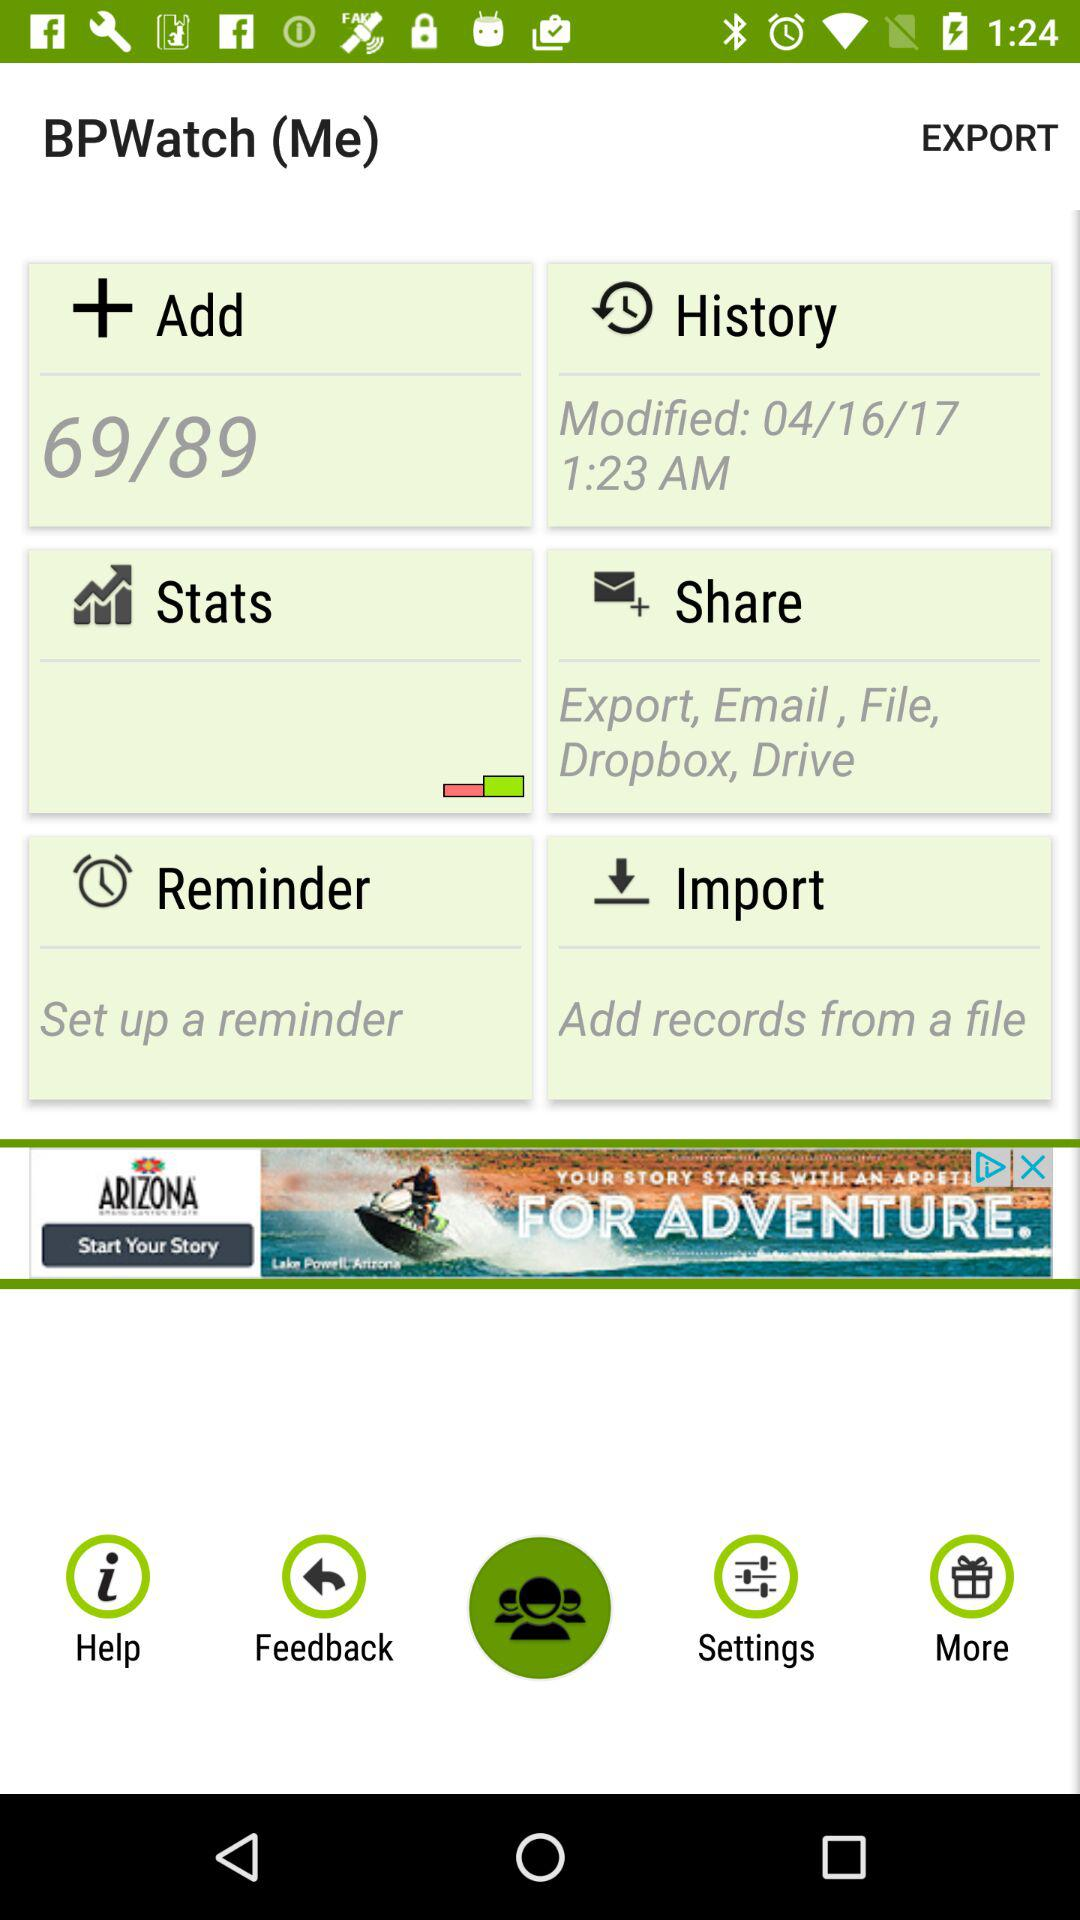What is the total count of items in "Add"? The total count of items is 89. 